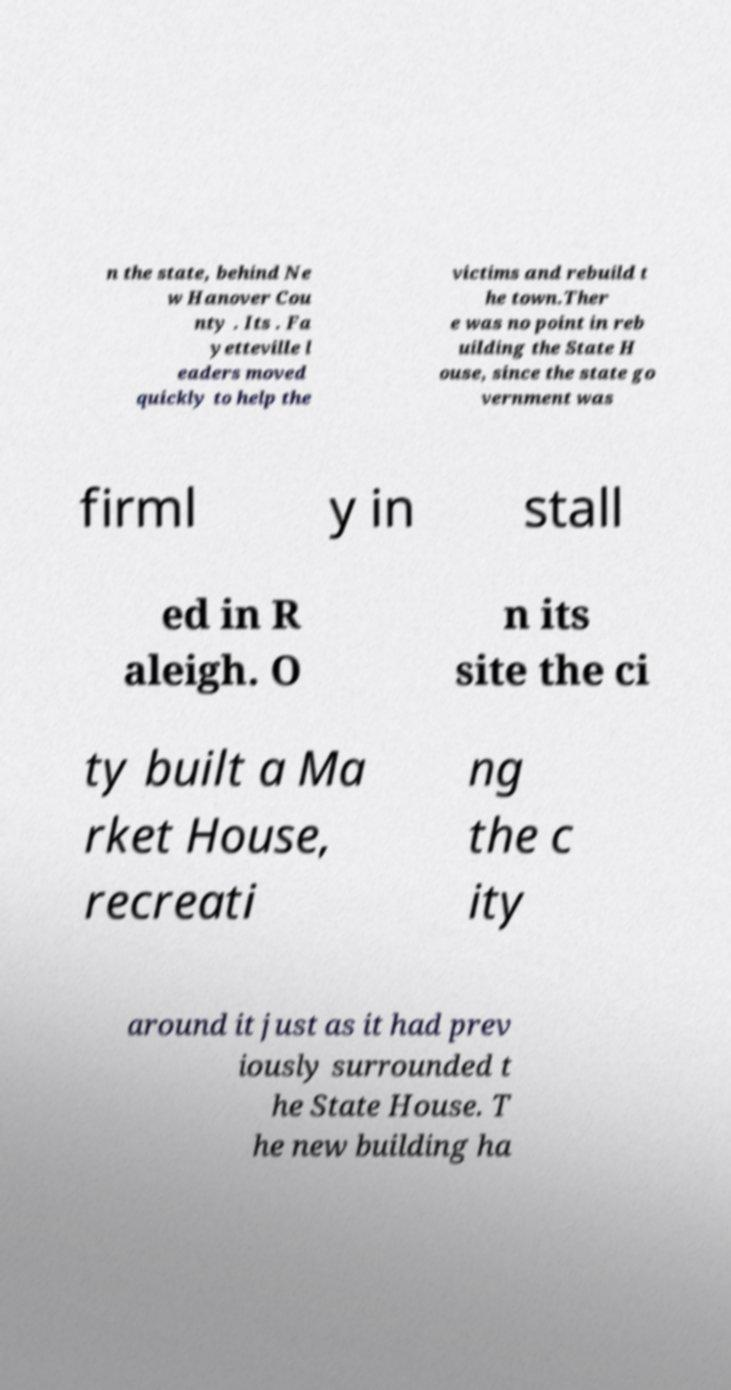Can you read and provide the text displayed in the image?This photo seems to have some interesting text. Can you extract and type it out for me? n the state, behind Ne w Hanover Cou nty . Its . Fa yetteville l eaders moved quickly to help the victims and rebuild t he town.Ther e was no point in reb uilding the State H ouse, since the state go vernment was firml y in stall ed in R aleigh. O n its site the ci ty built a Ma rket House, recreati ng the c ity around it just as it had prev iously surrounded t he State House. T he new building ha 